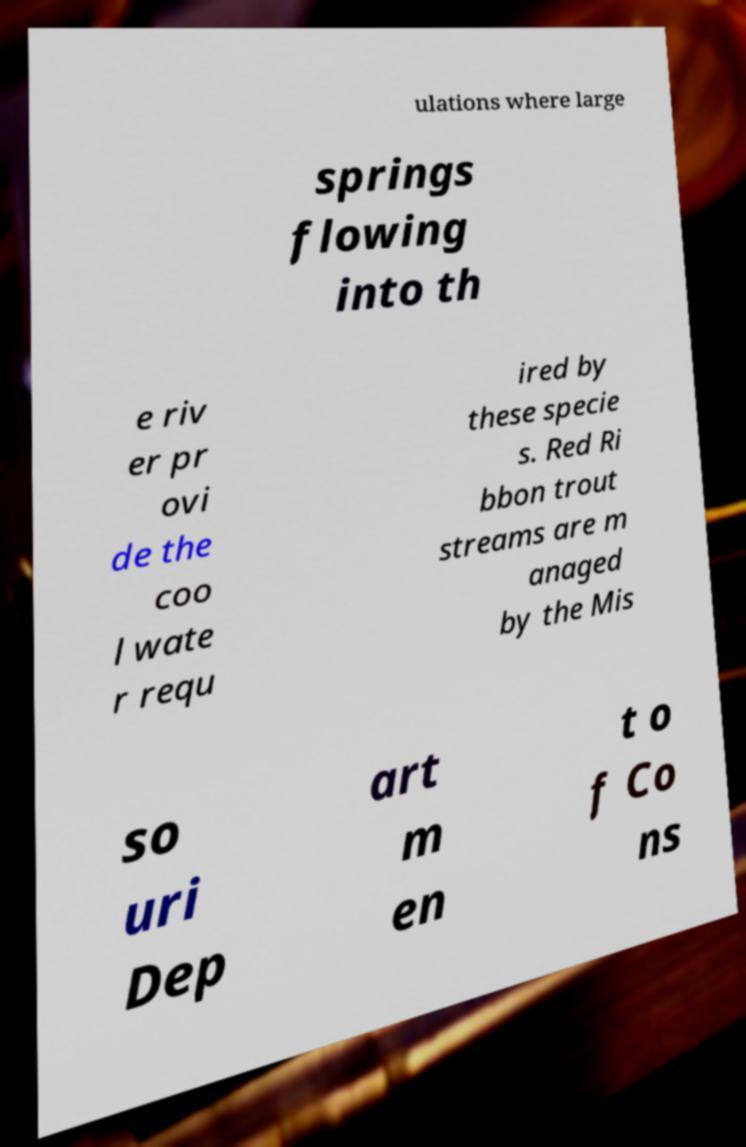Could you assist in decoding the text presented in this image and type it out clearly? ulations where large springs flowing into th e riv er pr ovi de the coo l wate r requ ired by these specie s. Red Ri bbon trout streams are m anaged by the Mis so uri Dep art m en t o f Co ns 